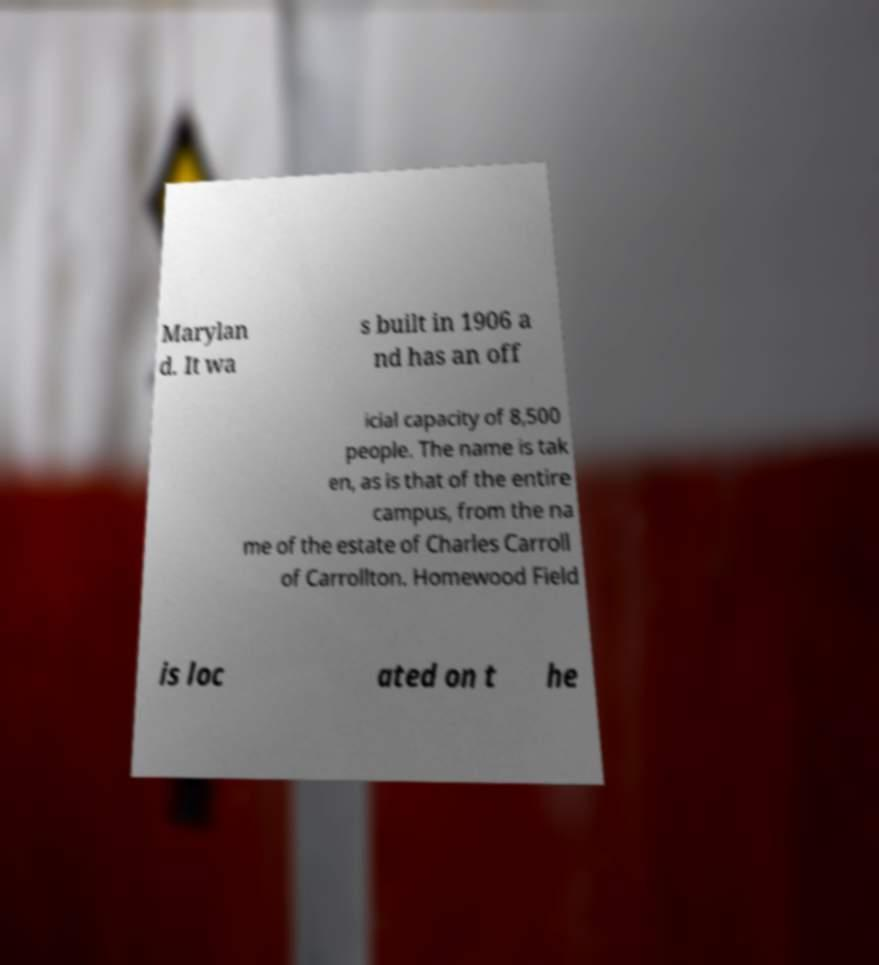Can you read and provide the text displayed in the image?This photo seems to have some interesting text. Can you extract and type it out for me? Marylan d. It wa s built in 1906 a nd has an off icial capacity of 8,500 people. The name is tak en, as is that of the entire campus, from the na me of the estate of Charles Carroll of Carrollton. Homewood Field is loc ated on t he 